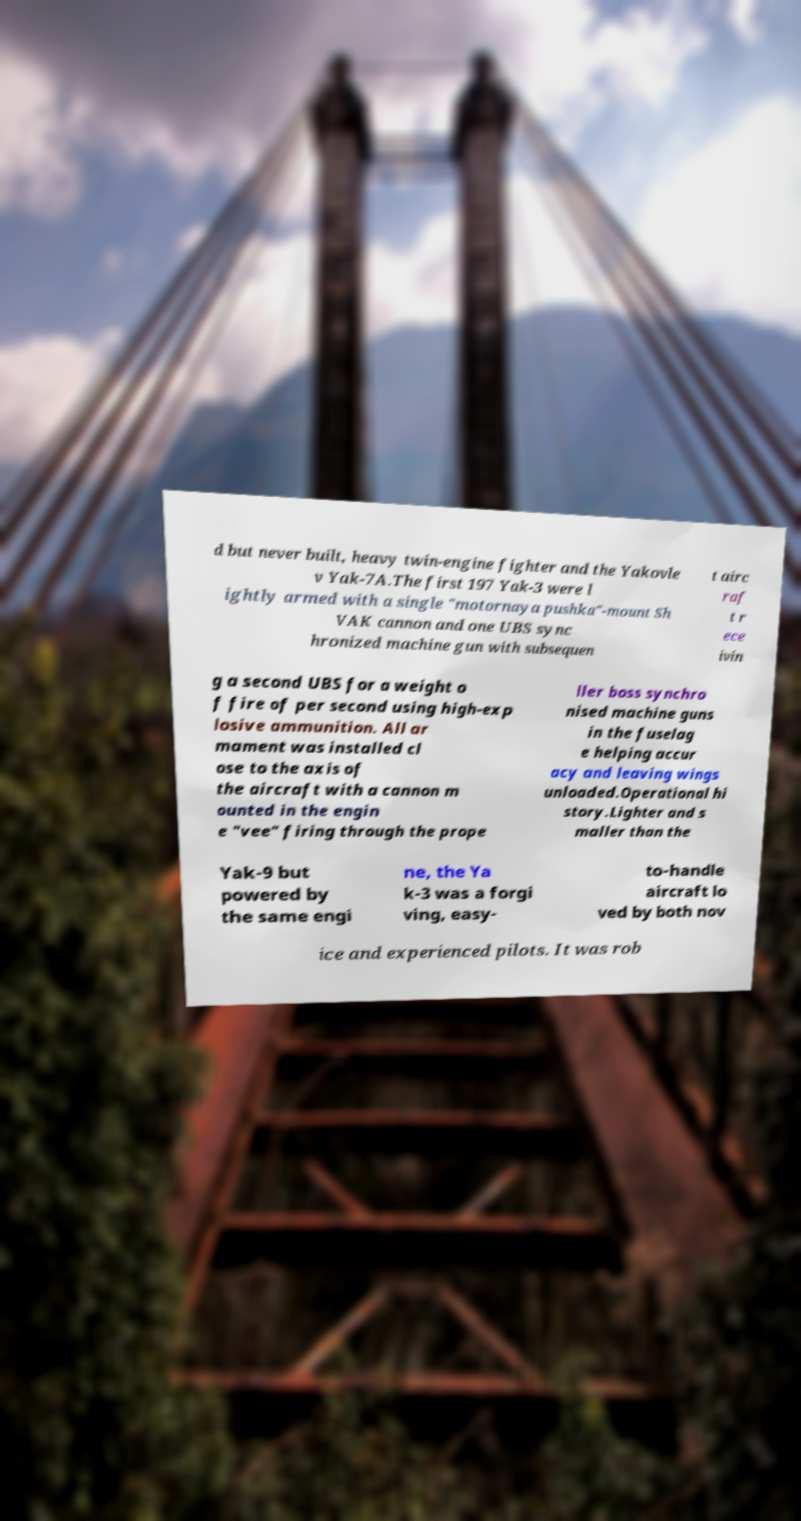What messages or text are displayed in this image? I need them in a readable, typed format. d but never built, heavy twin-engine fighter and the Yakovle v Yak-7A.The first 197 Yak-3 were l ightly armed with a single "motornaya pushka"-mount Sh VAK cannon and one UBS sync hronized machine gun with subsequen t airc raf t r ece ivin g a second UBS for a weight o f fire of per second using high-exp losive ammunition. All ar mament was installed cl ose to the axis of the aircraft with a cannon m ounted in the engin e "vee" firing through the prope ller boss synchro nised machine guns in the fuselag e helping accur acy and leaving wings unloaded.Operational hi story.Lighter and s maller than the Yak-9 but powered by the same engi ne, the Ya k-3 was a forgi ving, easy- to-handle aircraft lo ved by both nov ice and experienced pilots. It was rob 